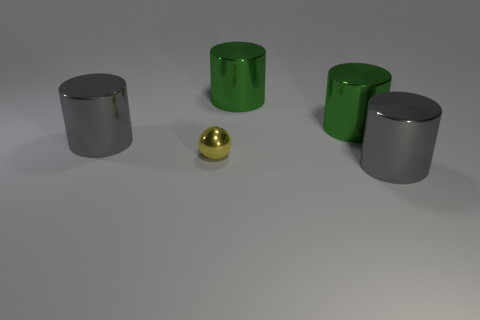Is there a tiny yellow cube made of the same material as the yellow ball? no 